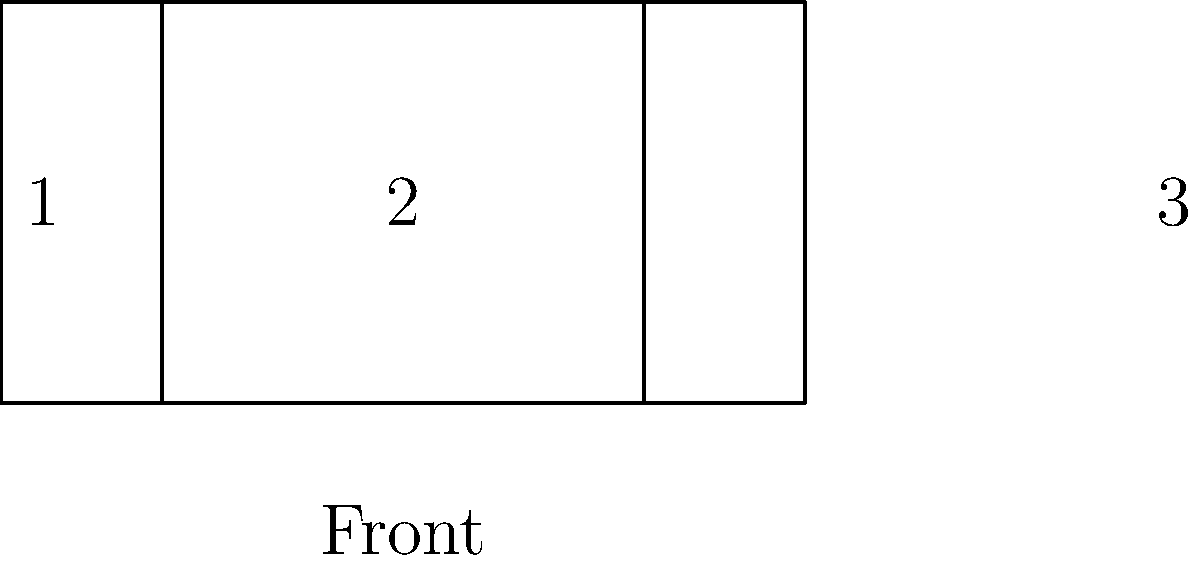In a typical German carnival parade float layout, which area is traditionally reserved for the main carnival society members or important figures? To answer this question, let's break down the layout of a typical German carnival parade float:

1. The diagram shows a top-down view of a carnival float, divided into three sections.

2. Section 1 is at the front of the float. This area is usually smaller and often used for musicians, dancers, or other performers who lead the float.

3. Section 2 is the largest area in the middle of the float. This central position is the most visible and prominent part of the float.

4. Section 3 is at the rear of the float. This area is often used for technical equipment, sound systems, or additional decorations.

5. In German carnival traditions, the main carnival society members, such as the Carnival Prince and Princess, or other important figures, are typically placed in the most visible and central position.

6. This central position allows them to be seen from all sides and interact with the crowd effectively.

Therefore, the area traditionally reserved for the main carnival society members or important figures is the central section, which is Section 2 in the diagram.
Answer: Section 2 (central area) 